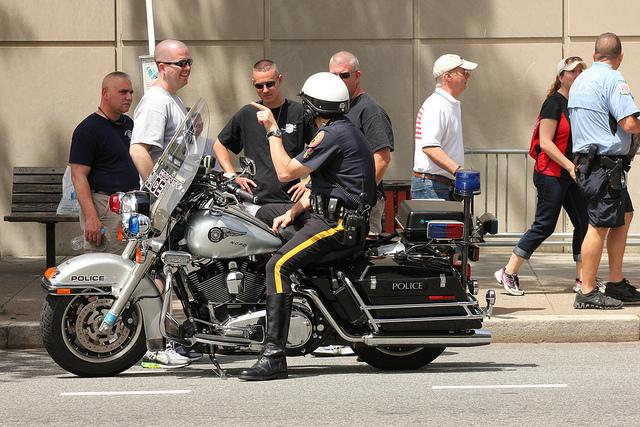How is the engine on this motorcycle cooled?

Choices:
A) pressure
B) oil
C) air
D) water air 